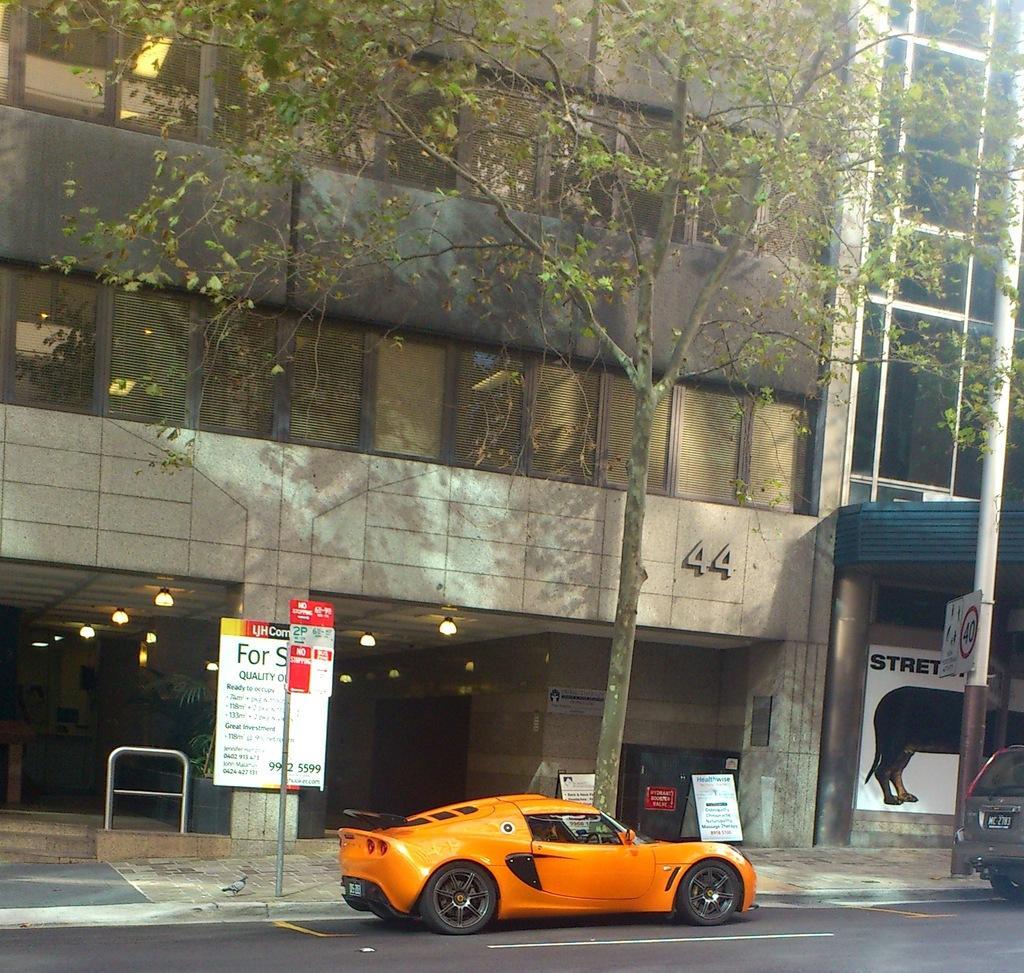Could you give a brief overview of what you see in this image? The picture is taken outside a city. In the foreground of the picture on the road, there are cars, hoardings, pole and tree. In the background there are buildings. In the background there are lights and plants. 